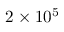Convert formula to latex. <formula><loc_0><loc_0><loc_500><loc_500>2 \times 1 0 ^ { 5 }</formula> 